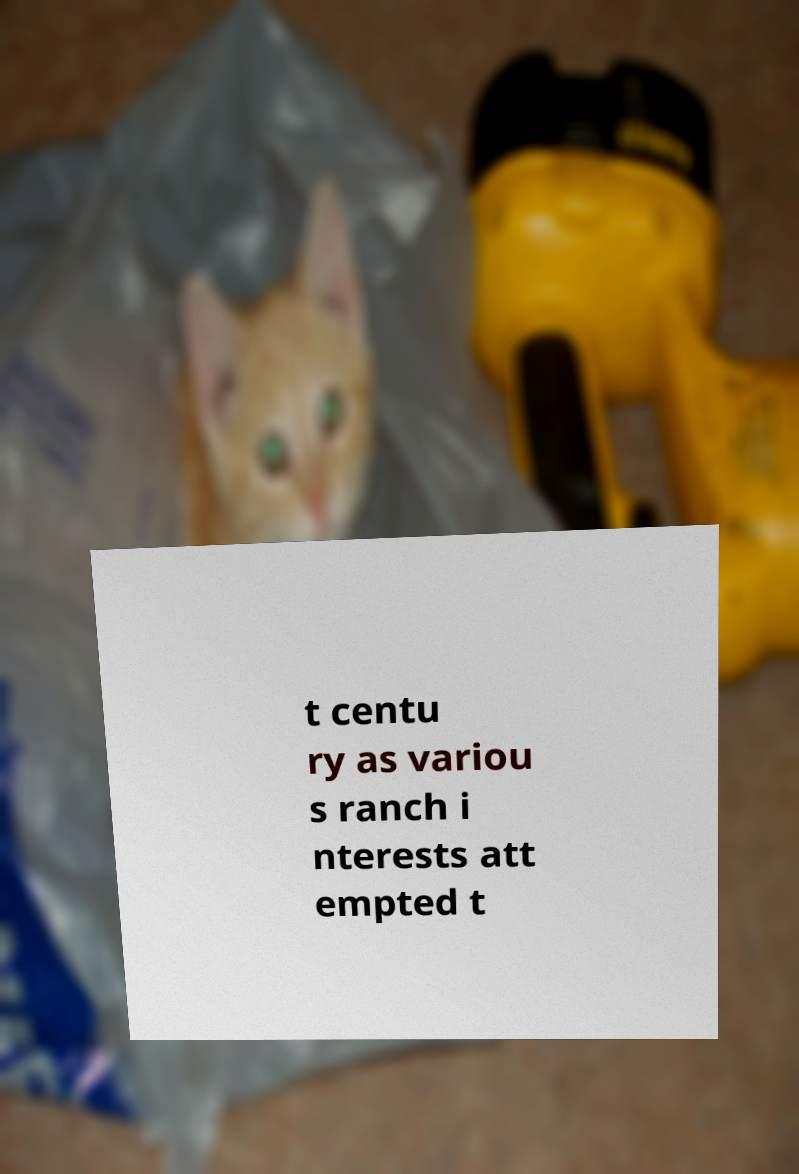Please read and relay the text visible in this image. What does it say? t centu ry as variou s ranch i nterests att empted t 